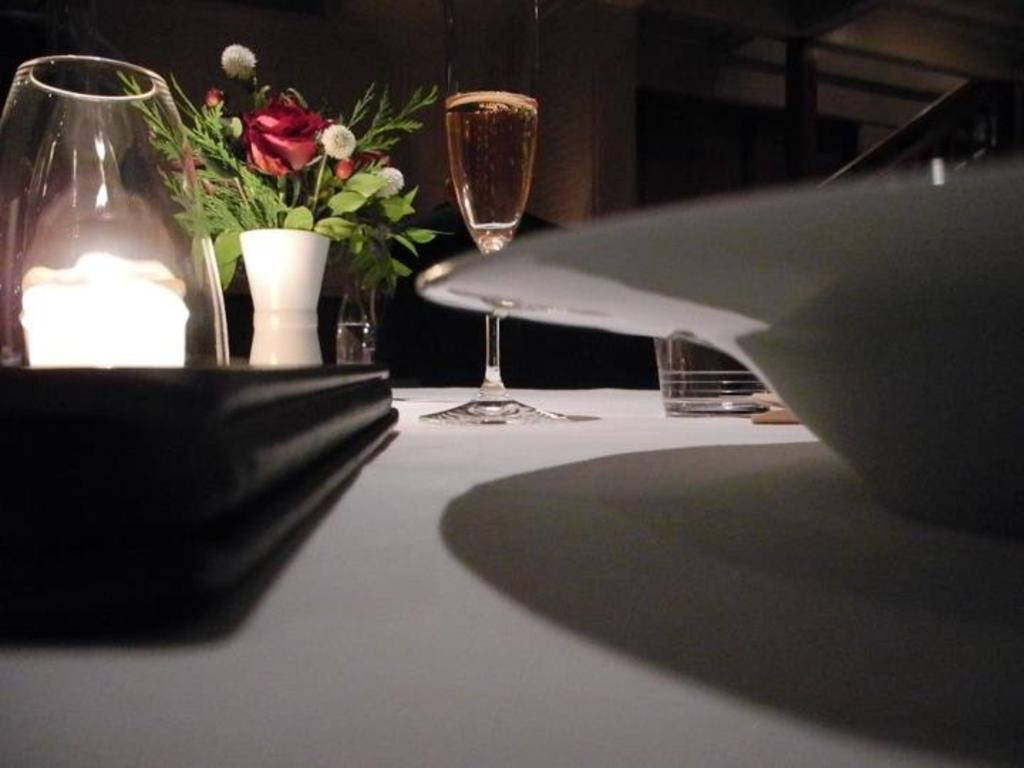What type of glasses are on the table in the image? There are wine glasses on the table. What other decorative item can be seen on the table? There is a flower vase on the table. What is the color of the glass that is not a wine glass? There is a blue glass on the table. What might be used for serving food on the table? There is a plate on the table. Where are the bushes located in the image? There are no bushes present in the image. What type of amusement can be seen in the image? There is no amusement activity or object present in the image. 